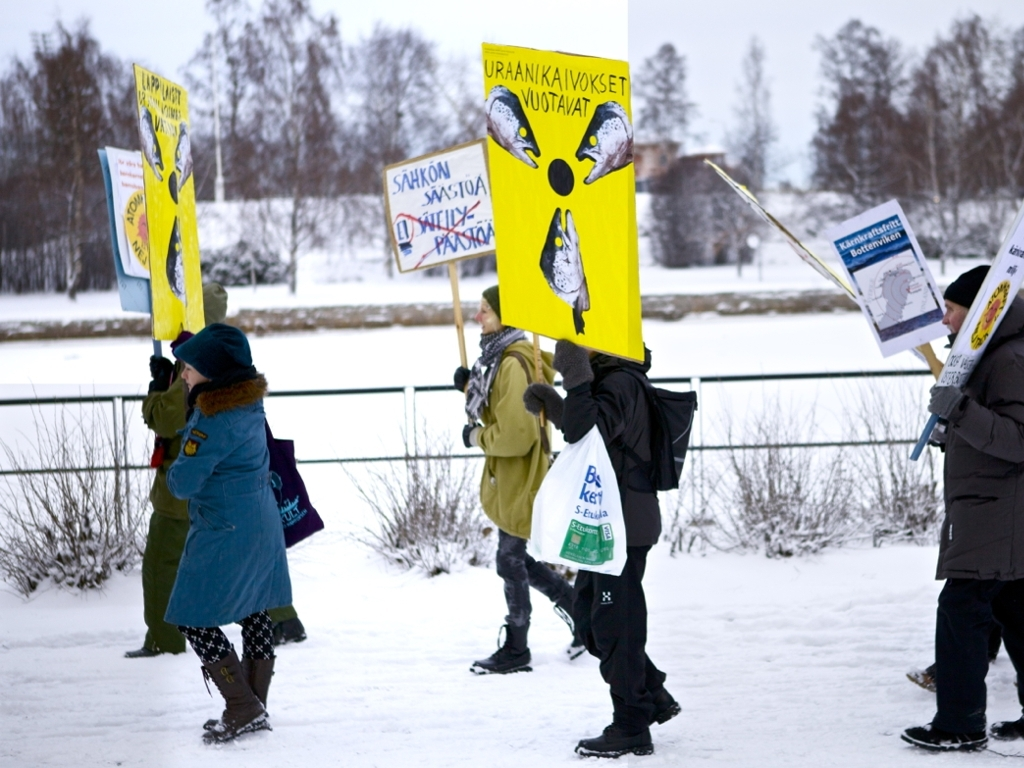What is the mood of the event depicted in this image? The event in the image appears to be a peaceful demonstration. The participants are holding signs with clear messages, suggesting that they are advocating for a cause or raising awareness about an issue. The overall mood seems purposeful and earnest, as the demonstrators are bundled up against the cold, showing commitment to their cause. 